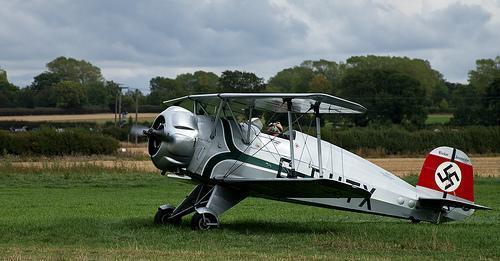How many propellers does the plane have?
Give a very brief answer. 1. 